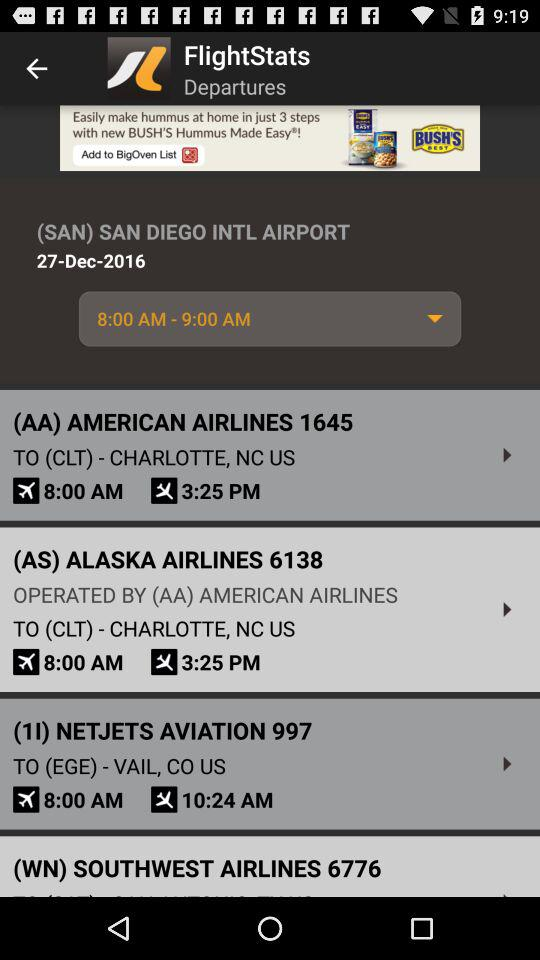What is the mentioned date? The mentioned date is December 27, 2016. 